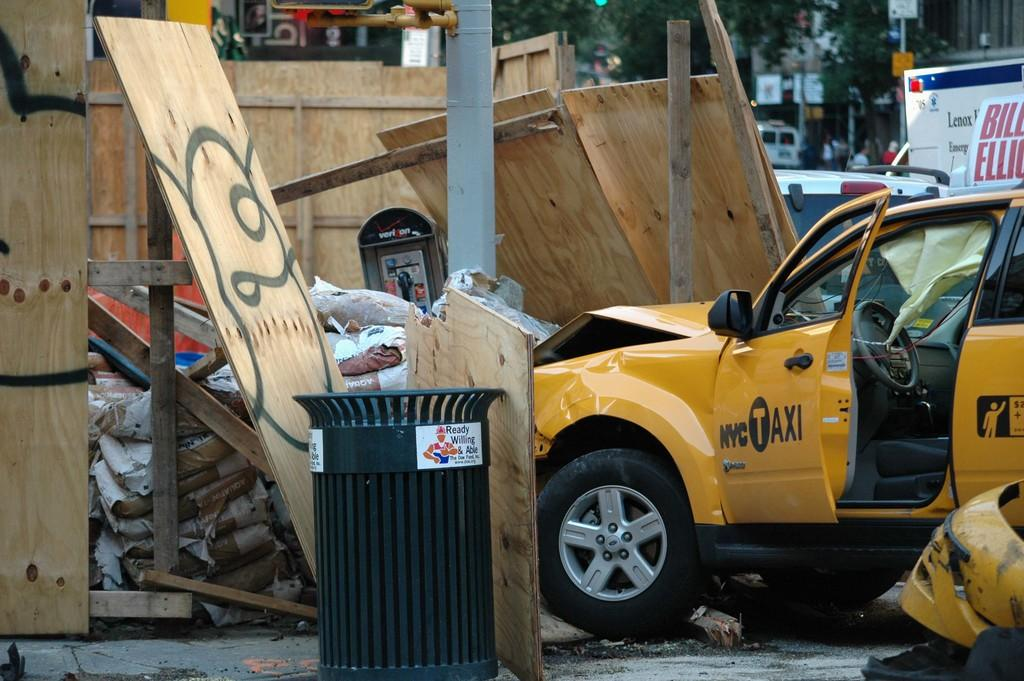<image>
Summarize the visual content of the image. A yellow car that says NYC Taxi is crashed into a wooden barrier. 